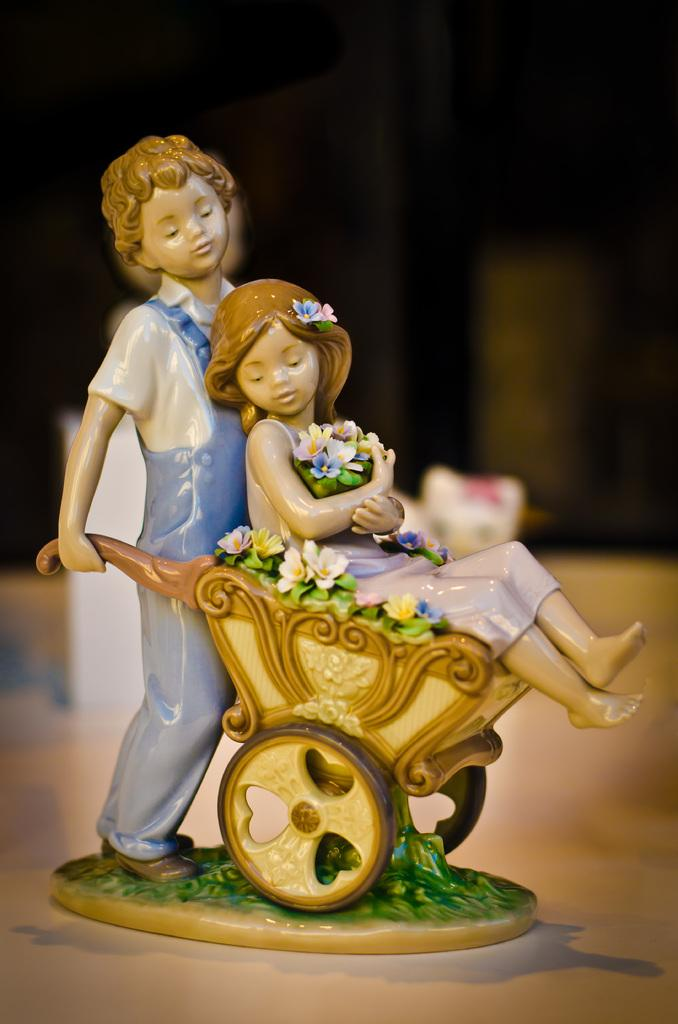What is the main subject of the image? There is a figure in the image. Where is the figure positioned in relation to the image? The figure is located in the center of the image. What is the figure resting on or placed upon? The figure is placed on a surface. What type of hearing aid is the figure wearing in the image? There is no hearing aid visible on the figure in the image. What is the figure's occupation, as indicated by their attire or surroundings? The image does not provide any information about the figure's occupation or attire, nor does it indicate any surroundings that might suggest their occupation. 